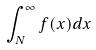Convert formula to latex. <formula><loc_0><loc_0><loc_500><loc_500>\int _ { N } ^ { \infty } f ( x ) d x</formula> 